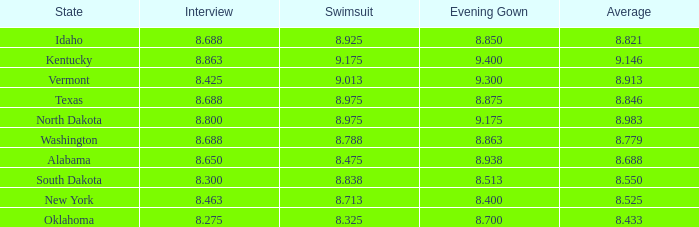846 has? None. 